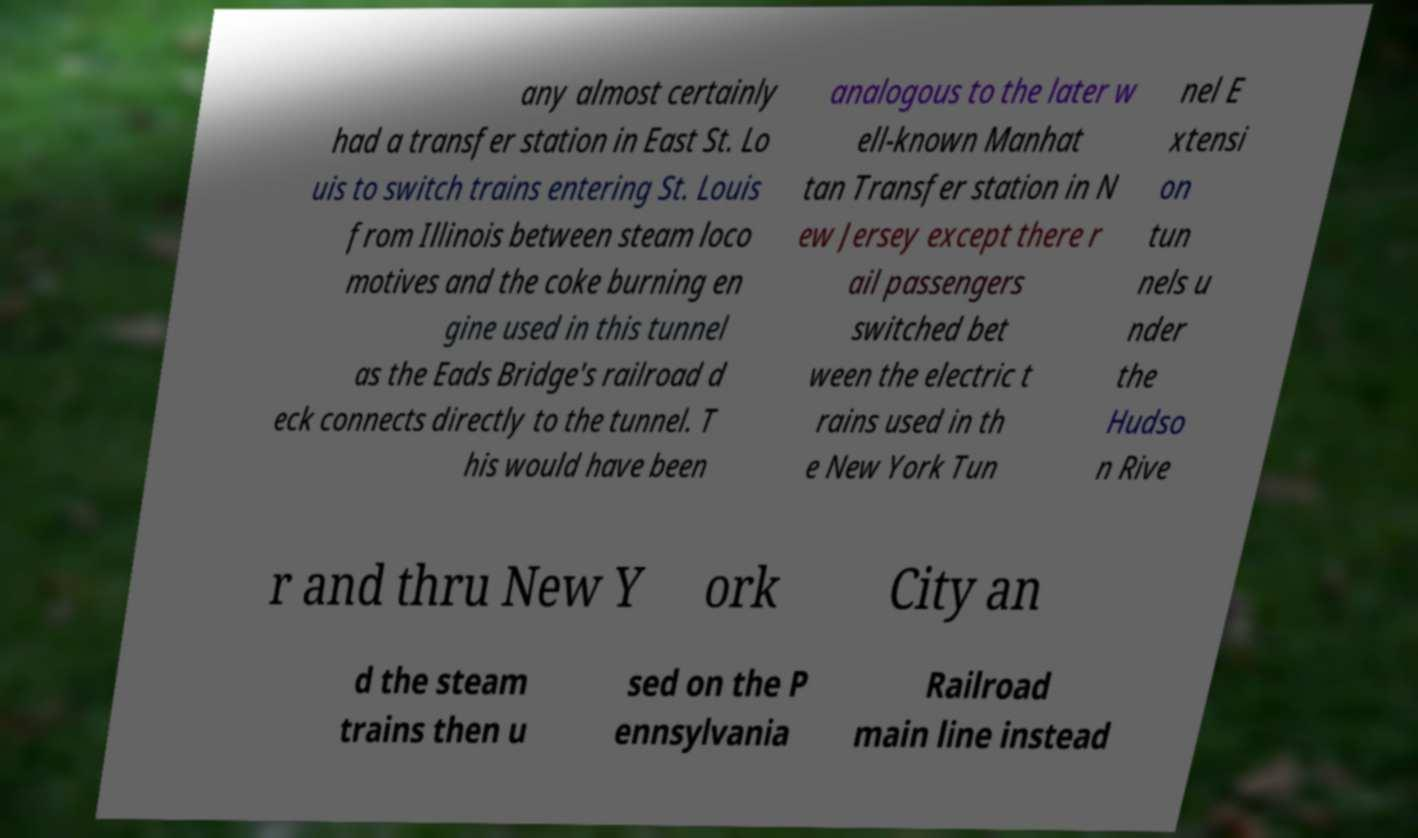Please identify and transcribe the text found in this image. any almost certainly had a transfer station in East St. Lo uis to switch trains entering St. Louis from Illinois between steam loco motives and the coke burning en gine used in this tunnel as the Eads Bridge's railroad d eck connects directly to the tunnel. T his would have been analogous to the later w ell-known Manhat tan Transfer station in N ew Jersey except there r ail passengers switched bet ween the electric t rains used in th e New York Tun nel E xtensi on tun nels u nder the Hudso n Rive r and thru New Y ork City an d the steam trains then u sed on the P ennsylvania Railroad main line instead 